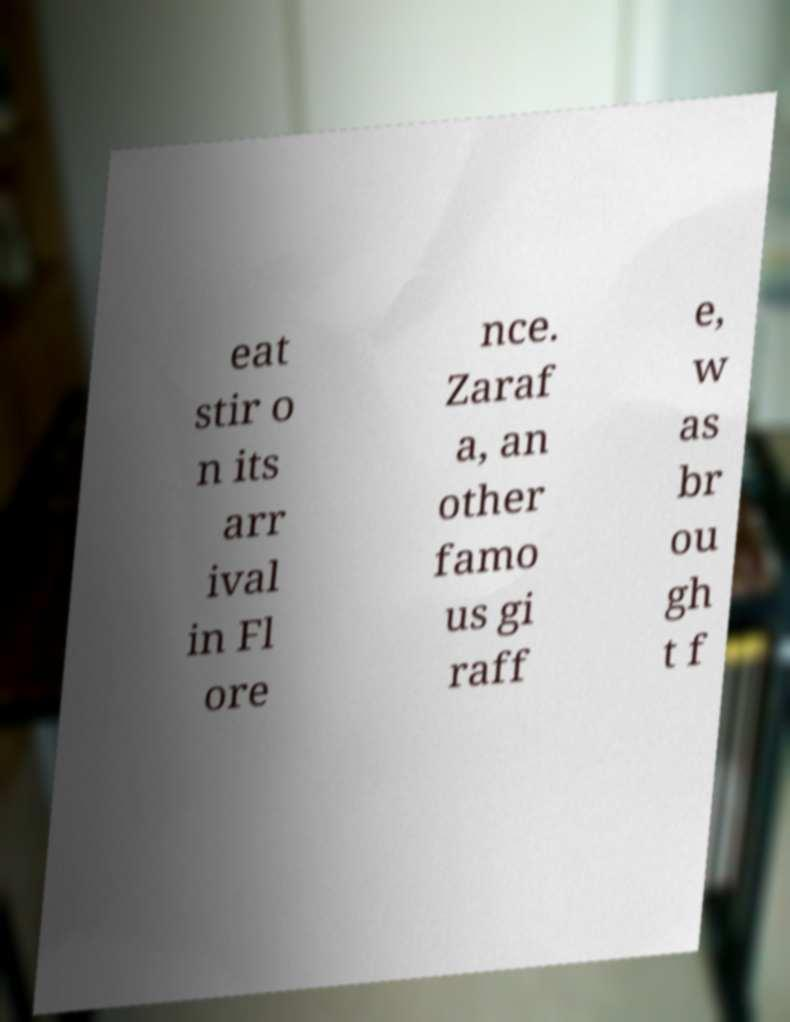Please read and relay the text visible in this image. What does it say? eat stir o n its arr ival in Fl ore nce. Zaraf a, an other famo us gi raff e, w as br ou gh t f 